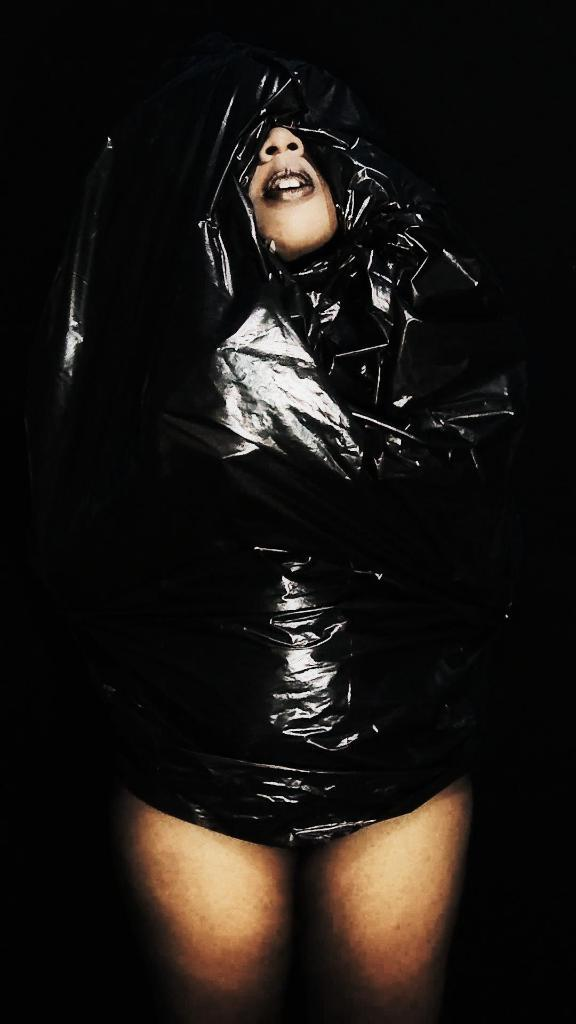What is the main subject of the image? There is a person in the image. What is the person doing in the image? The person is covering their face with a mask. What type of stew is being served to the women in the image? There are no women or stew present in the image; it only features a person wearing a mask. 